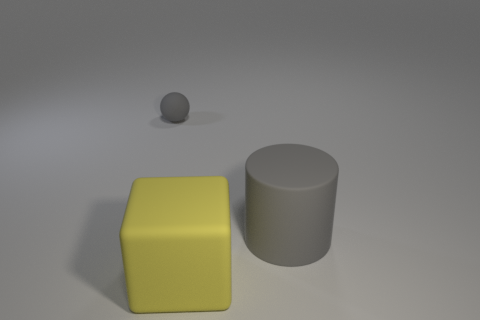Add 3 matte things. How many objects exist? 6 Subtract all cylinders. How many objects are left? 2 Subtract 0 yellow balls. How many objects are left? 3 Subtract all tiny cyan metal spheres. Subtract all large gray matte objects. How many objects are left? 2 Add 1 small matte balls. How many small matte balls are left? 2 Add 3 small gray objects. How many small gray objects exist? 4 